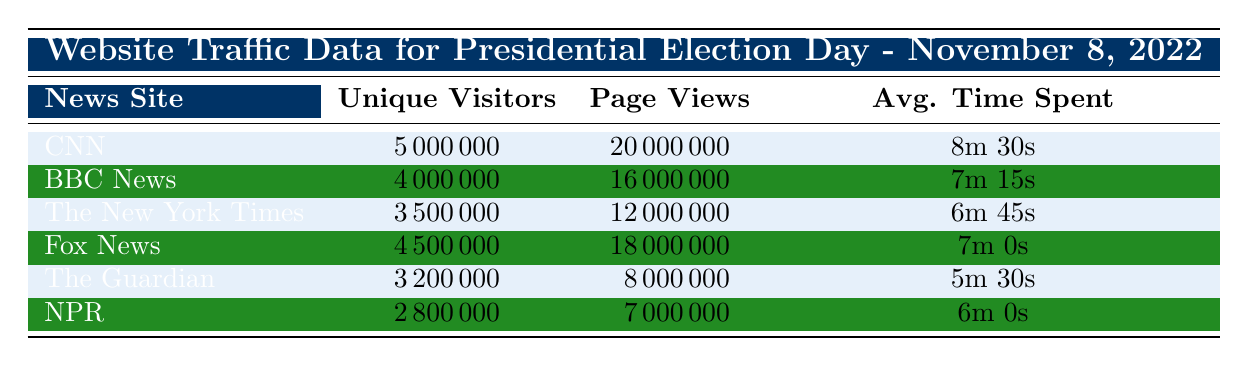What news site had the highest number of unique visitors on Election Day? From the table, CNN has the highest number of unique visitors, with a count of 5,000,000.
Answer: CNN How many unique visitors did The Guardian receive on Election Day? The table shows that The Guardian had 3,200,000 unique visitors on November 8, 2022.
Answer: 3,200,000 What is the total number of page views for all news sites combined on Election Day? To find the total page views, we add all the page views from each news site: 20,000,000 (CNN) + 16,000,000 (BBC News) + 12,000,000 (The New York Times) + 18,000,000 (Fox News) + 8,000,000 (The Guardian) + 7,000,000 (NPR) = 81,000,000.
Answer: 81,000,000 Is it true that Fox News had more average time spent than The New York Times? Based on the table, Fox News had an average time spent of 7 minutes while The New York Times had 6 minutes and 45 seconds. Therefore, it's true that Fox News had more average time spent than The New York Times.
Answer: Yes What is the average number of unique visitors across all news sites on Election Day? To find the average, we first sum the unique visitors: 5,000,000 + 4,000,000 + 3,500,000 + 4,500,000 + 3,200,000 + 2,800,000 = 23,000,000. Then, we divide by the number of news sites (6): 23,000,000 / 6 = 3,833,333.
Answer: 3,833,333 Which news site had the least average time spent by users? From the table, NPR had the least average time spent, at 6 minutes.
Answer: NPR Is the average time spent on BBC News greater than 7 minutes? The average time spent on BBC News is 7 minutes and 15 seconds, which is greater than 7 minutes.
Answer: Yes What difference in unique visitors separates CNN from the second highest, BBC News? CNN had 5,000,000 unique visitors, and BBC News had 4,000,000. The difference is 5,000,000 - 4,000,000 = 1,000,000 unique visitors.
Answer: 1,000,000 